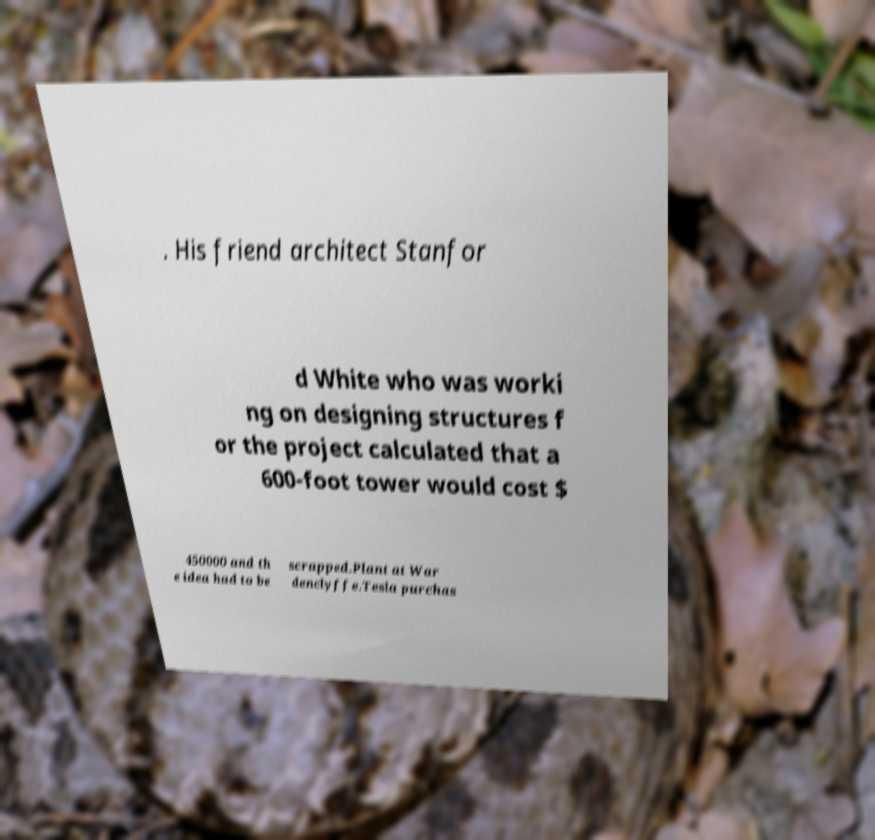Please identify and transcribe the text found in this image. . His friend architect Stanfor d White who was worki ng on designing structures f or the project calculated that a 600-foot tower would cost $ 450000 and th e idea had to be scrapped.Plant at War denclyffe.Tesla purchas 